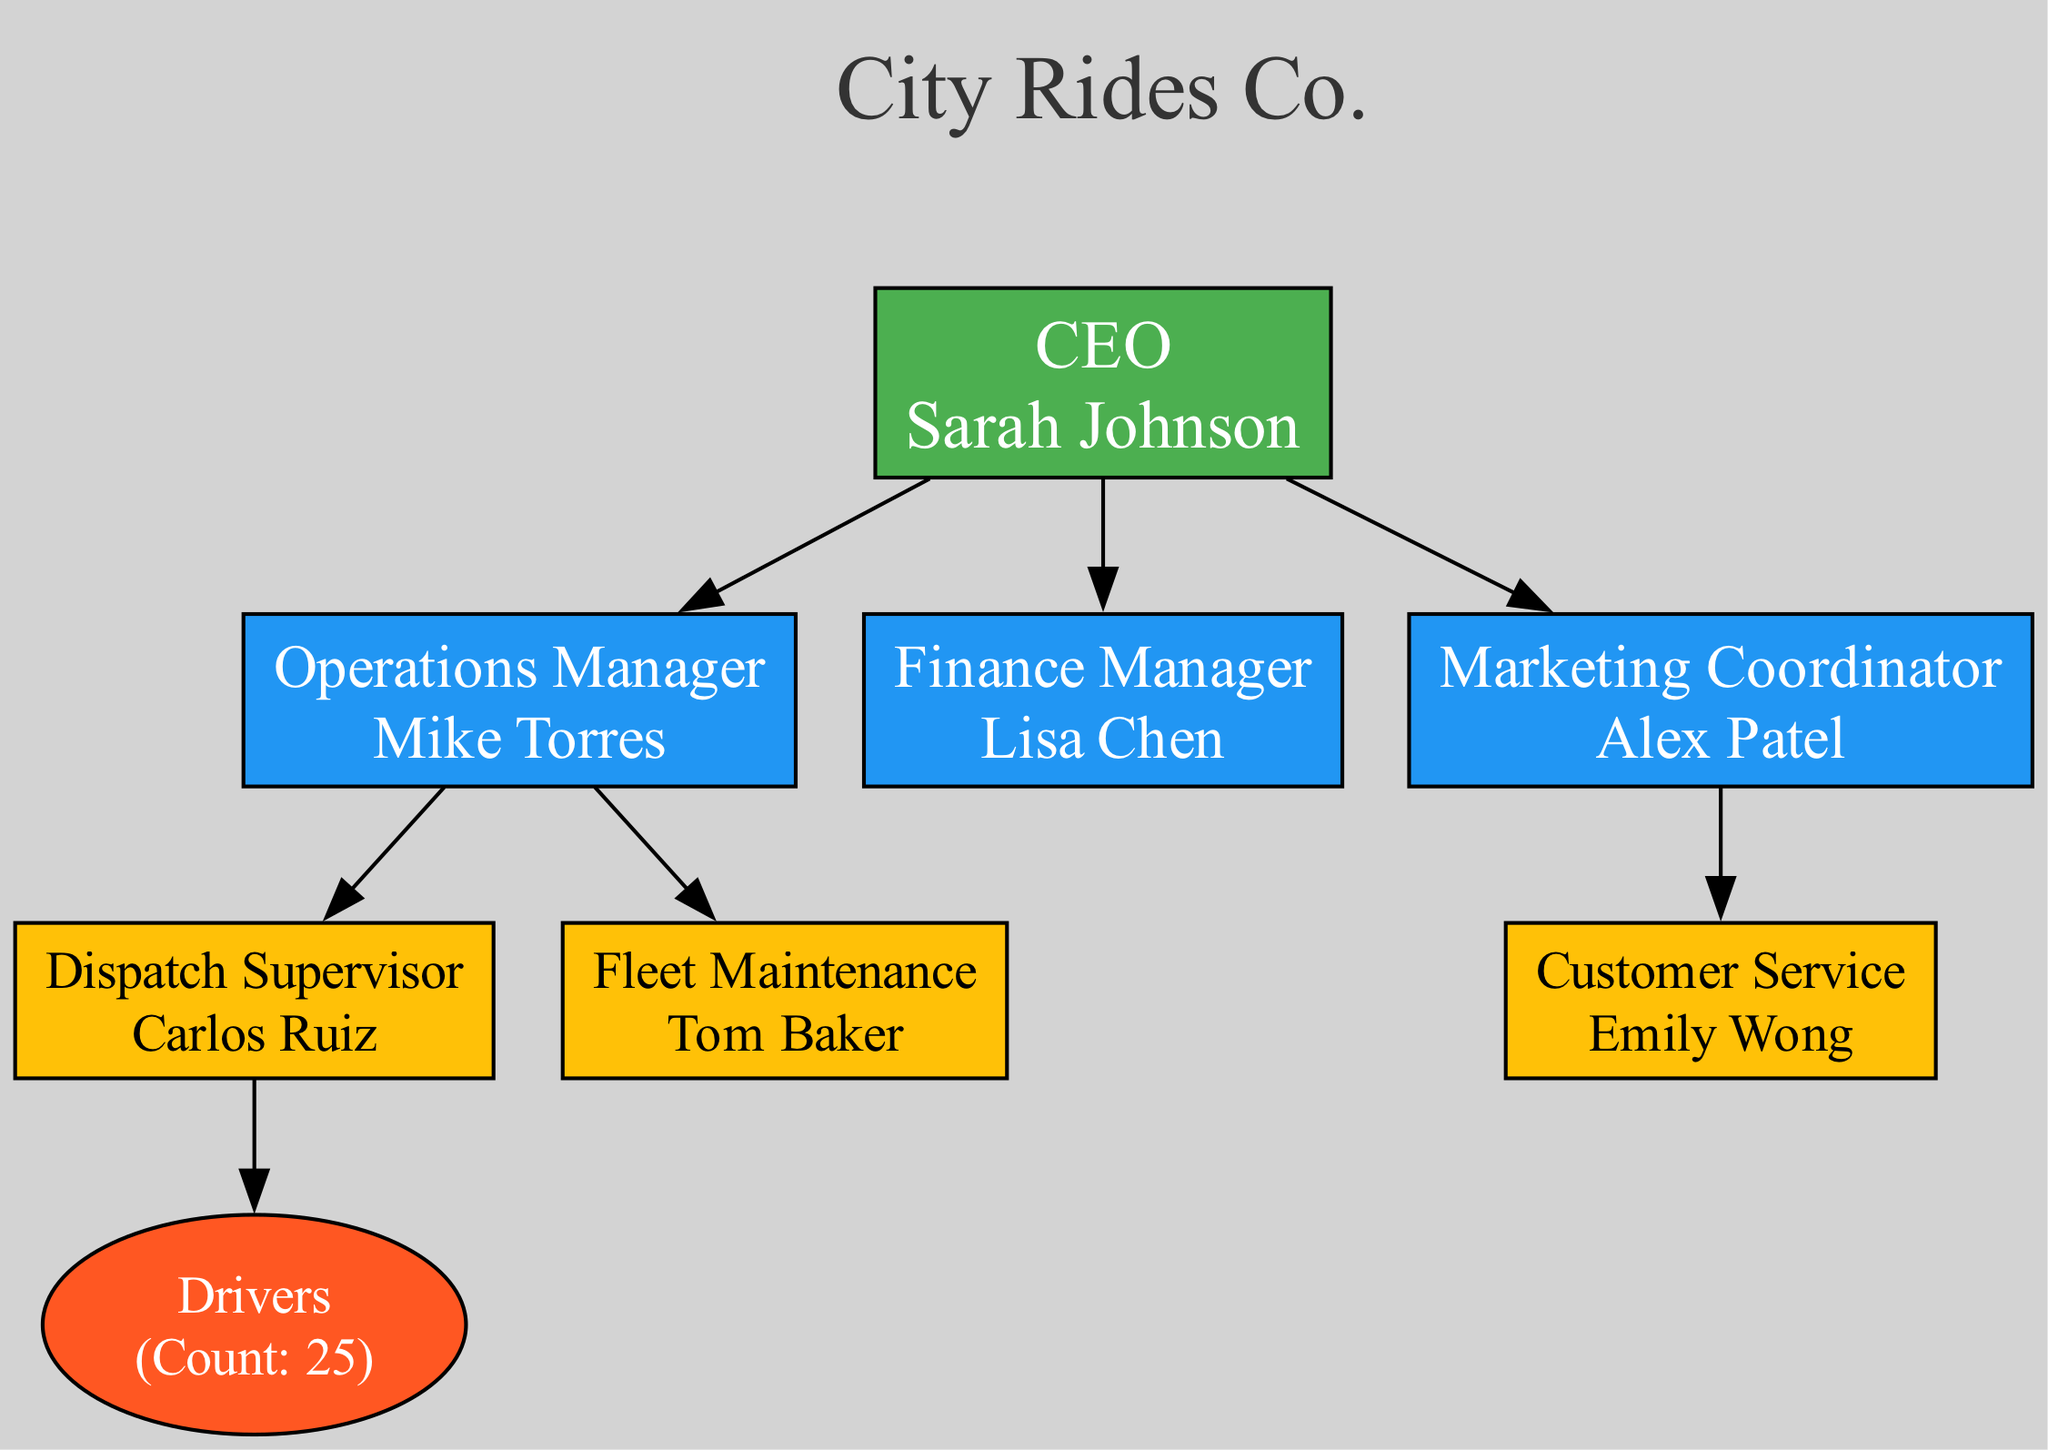What is the name of the CEO? The diagram shows the top-level role labeled as CEO, which is associated with the name Sarah Johnson. Therefore, the answer is the name displayed under the CEO node.
Answer: Sarah Johnson Who reports directly to the Operations Manager? The diagram indicates that both the Dispatch Supervisor (Carlos Ruiz) and Fleet Maintenance (Tom Baker) report to the Operations Manager. The question requires identifying these roles under the corresponding edge.
Answer: Carlos Ruiz, Tom Baker How many drivers are there? In the bottom level of the diagram, the role is labeled as Drivers, and the count is indicated as 25. Thus, the answer is the numerical value provided within the Drivers node.
Answer: 25 What color is the node for the Finance Manager? The diagram uses a specific color coding where the Finance Manager's node is filled with the color #2196F3, which is a shade of blue, as indicated in the second level of the structure.
Answer: Blue Which role does Emily Wong hold? The diagram identifies Emily Wong within the Customer Service node, which is situated in the third level and connected to the Marketing Coordinator. Thus, the answer is to reference the node that includes her name and role.
Answer: Customer Service Name one role that reports to the Marketing Coordinator. The diagram specifies that only the Customer Service role, held by Emily Wong, reports directly to the Marketing Coordinator. This information can be found by following the line connecting the Marketing Coordinator to the Customer Service node.
Answer: Customer Service How many total managerial roles are depicted in the second and third levels? The second level consists of three managerial roles (Operations Manager, Finance Manager, and Marketing Coordinator). The third level includes two roles (Dispatch Supervisor and Fleet Maintenance) under the Operations Manager. Adding these gives a total of five roles depicted in these levels.
Answer: 5 Which role is directly connected to the Drivers node? The Drivers node is connected to the Dispatch Supervisor node, as indicated by the edge that originates from the Dispatch Supervisor to the Drivers. This helps identify the direct relationship between these two roles.
Answer: Dispatch Supervisor What is the main role of Mike Torres? The diagram labels Mike Torres specifically as the Operations Manager in the second level of the structure. Therefore, the answer should reflect this role as depicted in the organizational chart.
Answer: Operations Manager 